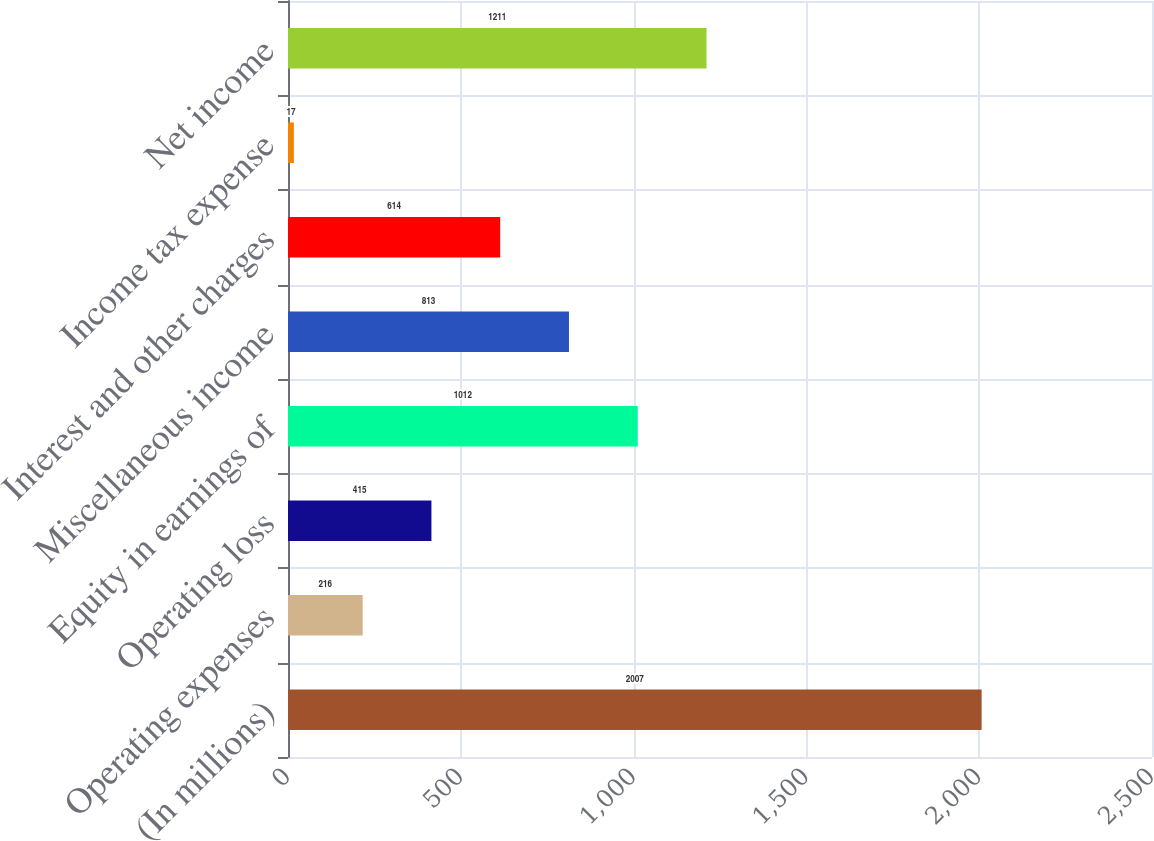Convert chart to OTSL. <chart><loc_0><loc_0><loc_500><loc_500><bar_chart><fcel>(In millions)<fcel>Operating expenses<fcel>Operating loss<fcel>Equity in earnings of<fcel>Miscellaneous income<fcel>Interest and other charges<fcel>Income tax expense<fcel>Net income<nl><fcel>2007<fcel>216<fcel>415<fcel>1012<fcel>813<fcel>614<fcel>17<fcel>1211<nl></chart> 